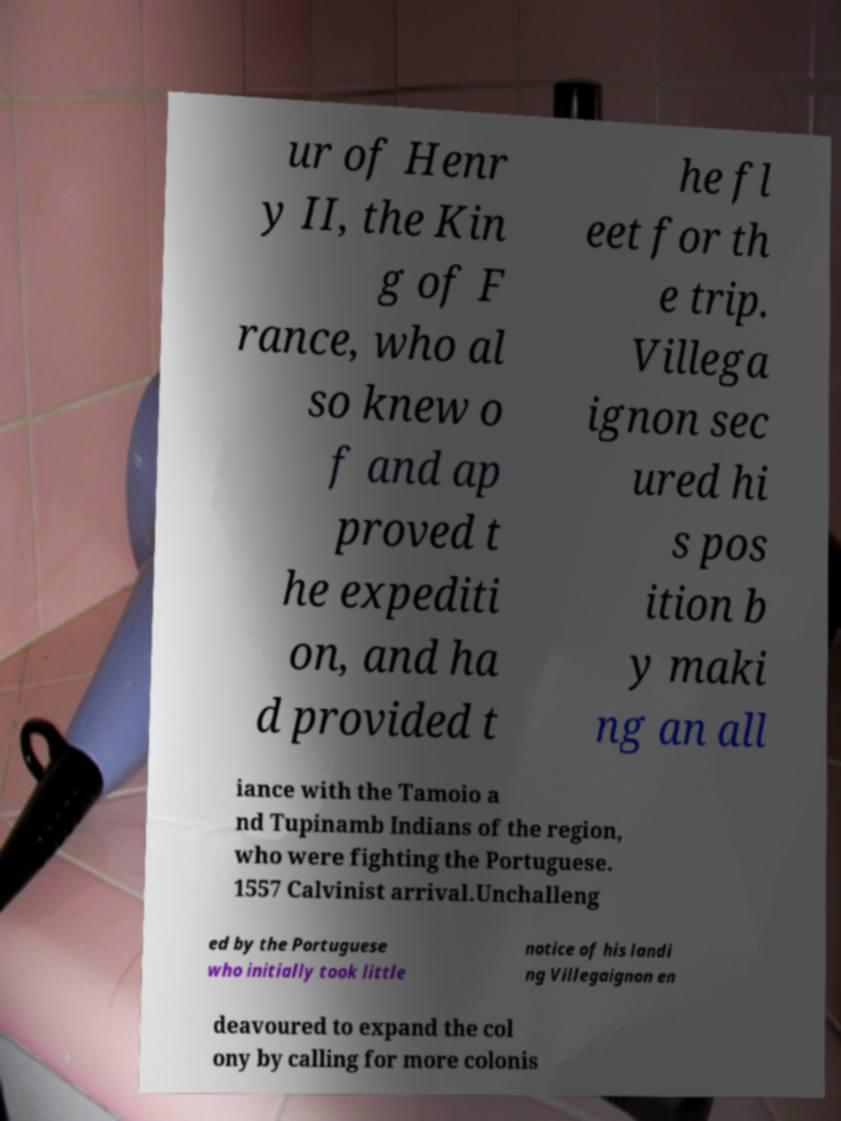Please identify and transcribe the text found in this image. ur of Henr y II, the Kin g of F rance, who al so knew o f and ap proved t he expediti on, and ha d provided t he fl eet for th e trip. Villega ignon sec ured hi s pos ition b y maki ng an all iance with the Tamoio a nd Tupinamb Indians of the region, who were fighting the Portuguese. 1557 Calvinist arrival.Unchalleng ed by the Portuguese who initially took little notice of his landi ng Villegaignon en deavoured to expand the col ony by calling for more colonis 